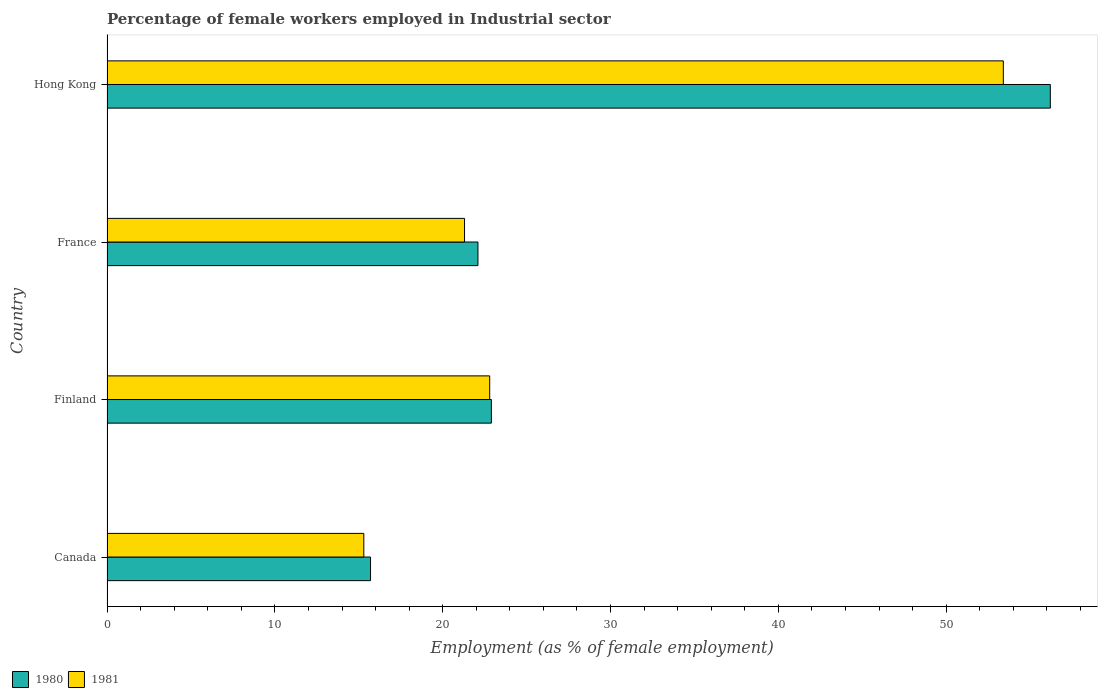How many different coloured bars are there?
Provide a short and direct response. 2. Are the number of bars per tick equal to the number of legend labels?
Your response must be concise. Yes. How many bars are there on the 3rd tick from the bottom?
Provide a short and direct response. 2. In how many cases, is the number of bars for a given country not equal to the number of legend labels?
Provide a short and direct response. 0. What is the percentage of females employed in Industrial sector in 1981 in Finland?
Offer a terse response. 22.8. Across all countries, what is the maximum percentage of females employed in Industrial sector in 1981?
Give a very brief answer. 53.4. Across all countries, what is the minimum percentage of females employed in Industrial sector in 1981?
Your response must be concise. 15.3. In which country was the percentage of females employed in Industrial sector in 1980 maximum?
Provide a short and direct response. Hong Kong. What is the total percentage of females employed in Industrial sector in 1981 in the graph?
Provide a short and direct response. 112.8. What is the difference between the percentage of females employed in Industrial sector in 1980 in Canada and that in France?
Your answer should be compact. -6.4. What is the difference between the percentage of females employed in Industrial sector in 1981 in Hong Kong and the percentage of females employed in Industrial sector in 1980 in Finland?
Your answer should be compact. 30.5. What is the average percentage of females employed in Industrial sector in 1980 per country?
Make the answer very short. 29.23. What is the difference between the percentage of females employed in Industrial sector in 1980 and percentage of females employed in Industrial sector in 1981 in Finland?
Provide a succinct answer. 0.1. In how many countries, is the percentage of females employed in Industrial sector in 1980 greater than 54 %?
Make the answer very short. 1. What is the ratio of the percentage of females employed in Industrial sector in 1981 in Finland to that in France?
Make the answer very short. 1.07. Is the difference between the percentage of females employed in Industrial sector in 1980 in Finland and France greater than the difference between the percentage of females employed in Industrial sector in 1981 in Finland and France?
Ensure brevity in your answer.  No. What is the difference between the highest and the second highest percentage of females employed in Industrial sector in 1980?
Provide a succinct answer. 33.3. What is the difference between the highest and the lowest percentage of females employed in Industrial sector in 1981?
Your response must be concise. 38.1. Is the sum of the percentage of females employed in Industrial sector in 1981 in Canada and France greater than the maximum percentage of females employed in Industrial sector in 1980 across all countries?
Your answer should be compact. No. What does the 2nd bar from the top in Canada represents?
Ensure brevity in your answer.  1980. What does the 1st bar from the bottom in Finland represents?
Make the answer very short. 1980. Are all the bars in the graph horizontal?
Provide a succinct answer. Yes. What is the difference between two consecutive major ticks on the X-axis?
Your response must be concise. 10. Does the graph contain grids?
Your answer should be compact. No. How are the legend labels stacked?
Offer a terse response. Horizontal. What is the title of the graph?
Give a very brief answer. Percentage of female workers employed in Industrial sector. What is the label or title of the X-axis?
Your response must be concise. Employment (as % of female employment). What is the Employment (as % of female employment) in 1980 in Canada?
Keep it short and to the point. 15.7. What is the Employment (as % of female employment) of 1981 in Canada?
Your answer should be very brief. 15.3. What is the Employment (as % of female employment) in 1980 in Finland?
Keep it short and to the point. 22.9. What is the Employment (as % of female employment) of 1981 in Finland?
Offer a very short reply. 22.8. What is the Employment (as % of female employment) in 1980 in France?
Offer a terse response. 22.1. What is the Employment (as % of female employment) in 1981 in France?
Your answer should be very brief. 21.3. What is the Employment (as % of female employment) of 1980 in Hong Kong?
Your response must be concise. 56.2. What is the Employment (as % of female employment) of 1981 in Hong Kong?
Your answer should be very brief. 53.4. Across all countries, what is the maximum Employment (as % of female employment) of 1980?
Provide a succinct answer. 56.2. Across all countries, what is the maximum Employment (as % of female employment) of 1981?
Your answer should be compact. 53.4. Across all countries, what is the minimum Employment (as % of female employment) of 1980?
Your response must be concise. 15.7. Across all countries, what is the minimum Employment (as % of female employment) of 1981?
Make the answer very short. 15.3. What is the total Employment (as % of female employment) of 1980 in the graph?
Ensure brevity in your answer.  116.9. What is the total Employment (as % of female employment) of 1981 in the graph?
Offer a very short reply. 112.8. What is the difference between the Employment (as % of female employment) in 1981 in Canada and that in Finland?
Your answer should be very brief. -7.5. What is the difference between the Employment (as % of female employment) in 1980 in Canada and that in Hong Kong?
Provide a succinct answer. -40.5. What is the difference between the Employment (as % of female employment) in 1981 in Canada and that in Hong Kong?
Your answer should be compact. -38.1. What is the difference between the Employment (as % of female employment) of 1980 in Finland and that in Hong Kong?
Offer a very short reply. -33.3. What is the difference between the Employment (as % of female employment) in 1981 in Finland and that in Hong Kong?
Your answer should be compact. -30.6. What is the difference between the Employment (as % of female employment) in 1980 in France and that in Hong Kong?
Your answer should be compact. -34.1. What is the difference between the Employment (as % of female employment) of 1981 in France and that in Hong Kong?
Make the answer very short. -32.1. What is the difference between the Employment (as % of female employment) in 1980 in Canada and the Employment (as % of female employment) in 1981 in Hong Kong?
Ensure brevity in your answer.  -37.7. What is the difference between the Employment (as % of female employment) of 1980 in Finland and the Employment (as % of female employment) of 1981 in France?
Provide a short and direct response. 1.6. What is the difference between the Employment (as % of female employment) in 1980 in Finland and the Employment (as % of female employment) in 1981 in Hong Kong?
Provide a succinct answer. -30.5. What is the difference between the Employment (as % of female employment) of 1980 in France and the Employment (as % of female employment) of 1981 in Hong Kong?
Offer a terse response. -31.3. What is the average Employment (as % of female employment) of 1980 per country?
Offer a very short reply. 29.23. What is the average Employment (as % of female employment) of 1981 per country?
Provide a short and direct response. 28.2. What is the ratio of the Employment (as % of female employment) of 1980 in Canada to that in Finland?
Keep it short and to the point. 0.69. What is the ratio of the Employment (as % of female employment) of 1981 in Canada to that in Finland?
Provide a succinct answer. 0.67. What is the ratio of the Employment (as % of female employment) in 1980 in Canada to that in France?
Your answer should be very brief. 0.71. What is the ratio of the Employment (as % of female employment) of 1981 in Canada to that in France?
Your answer should be very brief. 0.72. What is the ratio of the Employment (as % of female employment) in 1980 in Canada to that in Hong Kong?
Offer a very short reply. 0.28. What is the ratio of the Employment (as % of female employment) of 1981 in Canada to that in Hong Kong?
Offer a terse response. 0.29. What is the ratio of the Employment (as % of female employment) of 1980 in Finland to that in France?
Your response must be concise. 1.04. What is the ratio of the Employment (as % of female employment) in 1981 in Finland to that in France?
Offer a very short reply. 1.07. What is the ratio of the Employment (as % of female employment) of 1980 in Finland to that in Hong Kong?
Keep it short and to the point. 0.41. What is the ratio of the Employment (as % of female employment) of 1981 in Finland to that in Hong Kong?
Your answer should be very brief. 0.43. What is the ratio of the Employment (as % of female employment) of 1980 in France to that in Hong Kong?
Your response must be concise. 0.39. What is the ratio of the Employment (as % of female employment) in 1981 in France to that in Hong Kong?
Offer a terse response. 0.4. What is the difference between the highest and the second highest Employment (as % of female employment) of 1980?
Your answer should be very brief. 33.3. What is the difference between the highest and the second highest Employment (as % of female employment) in 1981?
Make the answer very short. 30.6. What is the difference between the highest and the lowest Employment (as % of female employment) of 1980?
Offer a very short reply. 40.5. What is the difference between the highest and the lowest Employment (as % of female employment) of 1981?
Offer a very short reply. 38.1. 